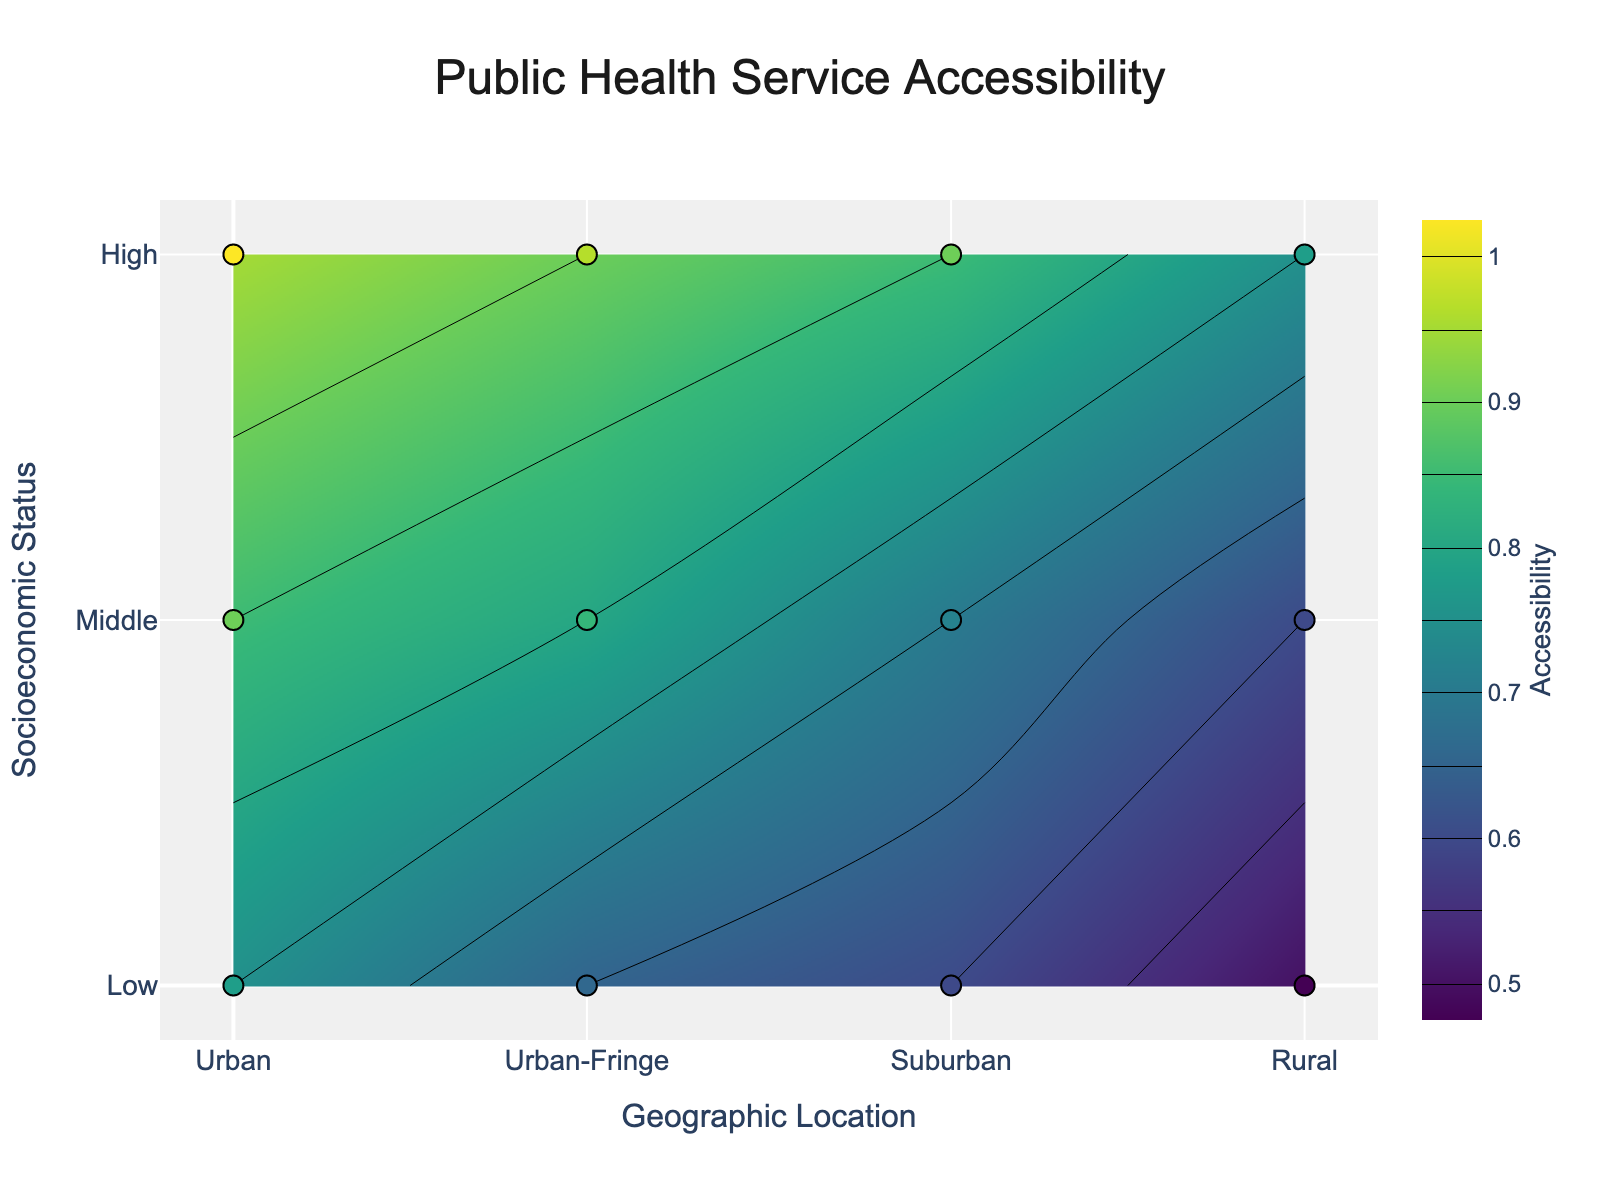What is the title of the plot? The title is located at the top center of the plot and clearly stated to inform the viewer about the main topic of the visualization.
Answer: Public Health Service Accessibility What does the color bar represent? The color bar on the right side of the plot denotes the scale of health service accessibility, ranging from 0.5 to 1.
Answer: Health Service Accessibility How are the geographic locations represented on the x-axis? The x-axis is labeled 'Geographic Location' and includes tick texts for 'Urban', 'Urban-Fringe', 'Suburban', and 'Rural', with corresponding numeric values of 0, 0.33, 0.67, and 1, respectively.
Answer: Urban, Urban-Fringe, Suburban, Rural Which socioeconomic status has the highest health service accessibility in urban areas? By examining the urban data point (x=0), the highest health service accessibility value on the y-axis corresponds to the 'High' socioeconomic status.
Answer: High Compare the accessibility of health services between urban and rural areas for the 'Low' socioeconomic status. The contour plot shows the accessibility for 'Low' status (y=0) at different geographic locations. Urban (x=0) has a value of 0.75, whereas Rural (x=1) has a value of 0.50.
Answer: Urban has higher accessibility What is the difference in health service accessibility between the 'Middle' socioeconomic status in urban and suburban areas? The accessibility for 'Middle' status (y=0.5) in urban (x=0) is 0.85 and in suburban (x=0.67) is 0.70. The difference is calculated as 0.85 - 0.70.
Answer: 0.15 Which geographic location has the lowest health service accessibility for the 'High' socioeconomic status? For 'High' status (y=1), we need to identify the lowest value among various locations: Urban (0.95), Urban-Fringe (0.90), Suburban (0.85), and Rural (0.75). The lowest value is with Rural.
Answer: Rural What geographic trend is observable for health service accessibility for all socioeconomic statuses? The plot shows a general decrease in health service accessibility as the geographic location shifts from Urban to Rural across all socioeconomic statuses. This is inferred from the descending values moving to the right along the x-axis.
Answer: Decrease from Urban to Rural 